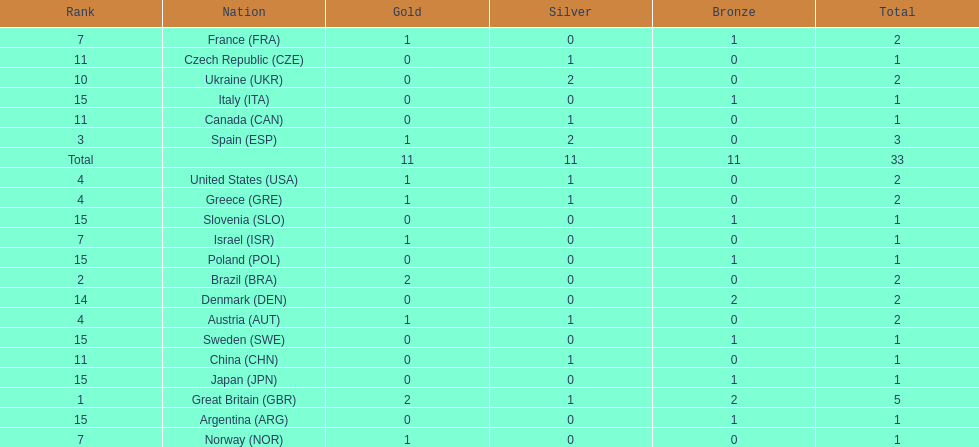What was the total number of medals won by united states? 2. 